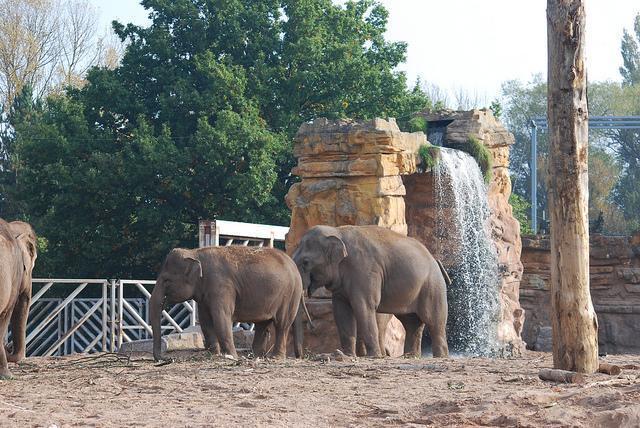How many elephants are seen in the image?
Give a very brief answer. 3. How many elephants are there?
Give a very brief answer. 3. How many oranges are in the tray?
Give a very brief answer. 0. 